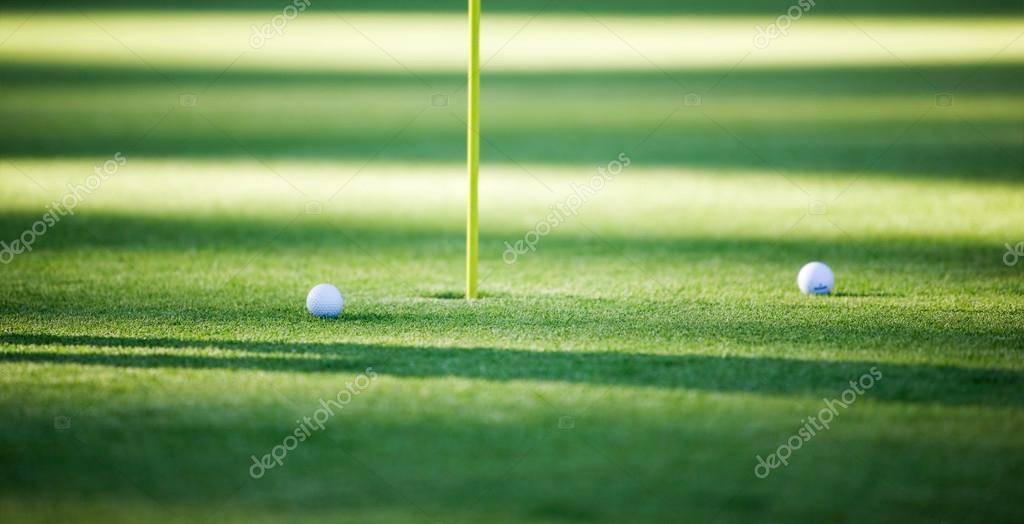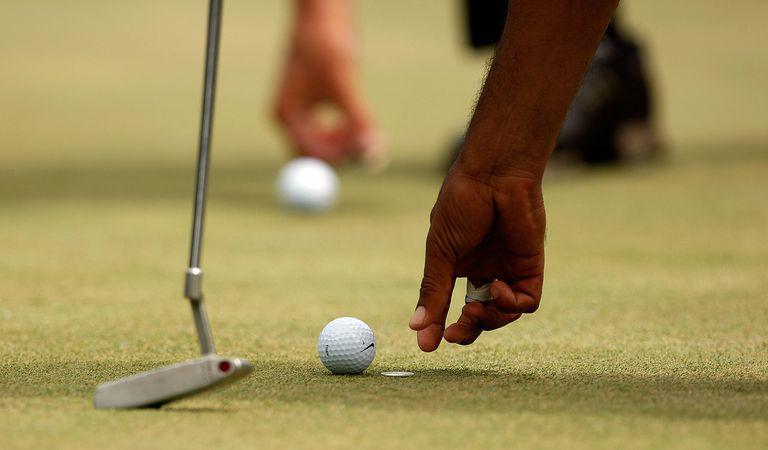The first image is the image on the left, the second image is the image on the right. Examine the images to the left and right. Is the description "two balls are placed side by side in front of a dome type cover" accurate? Answer yes or no. No. 